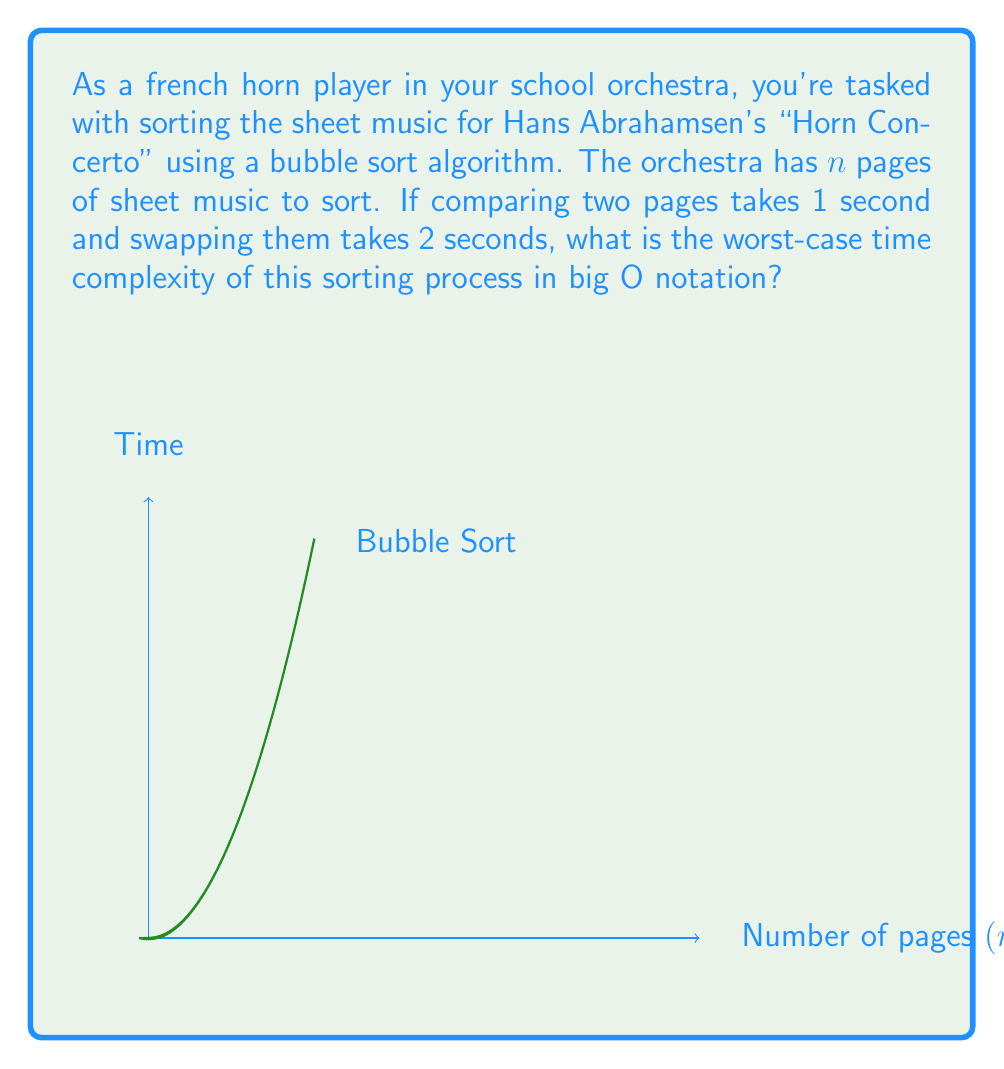What is the answer to this math problem? Let's analyze this step-by-step:

1) Bubble sort involves repeatedly stepping through the list, comparing adjacent elements and swapping them if they're in the wrong order.

2) In the worst-case scenario (when the list is in reverse order):
   - We need to make $n-1$ passes through the list.
   - In each pass, we make up to $n-1$ comparisons and potentially $n-1$ swaps.

3) The number of comparisons in the worst case is:
   $$(n-1) + (n-2) + ... + 2 + 1 = \frac{n(n-1)}{2}$$

4) The number of swaps in the worst case is the same:
   $$\frac{n(n-1)}{2}$$

5) Each comparison takes 1 second and each swap takes 2 seconds, so the total time is:
   $$T(n) = 1 \cdot \frac{n(n-1)}{2} + 2 \cdot \frac{n(n-1)}{2} = \frac{3n(n-1)}{2}$$

6) Expanding this:
   $$T(n) = \frac{3n^2 - 3n}{2}$$

7) In big O notation, we only care about the highest order term and ignore constants, so:
   $$T(n) = O(n^2)$$

Therefore, the worst-case time complexity of bubble sort for arranging the sheet music is quadratic, or $O(n^2)$.
Answer: $O(n^2)$ 